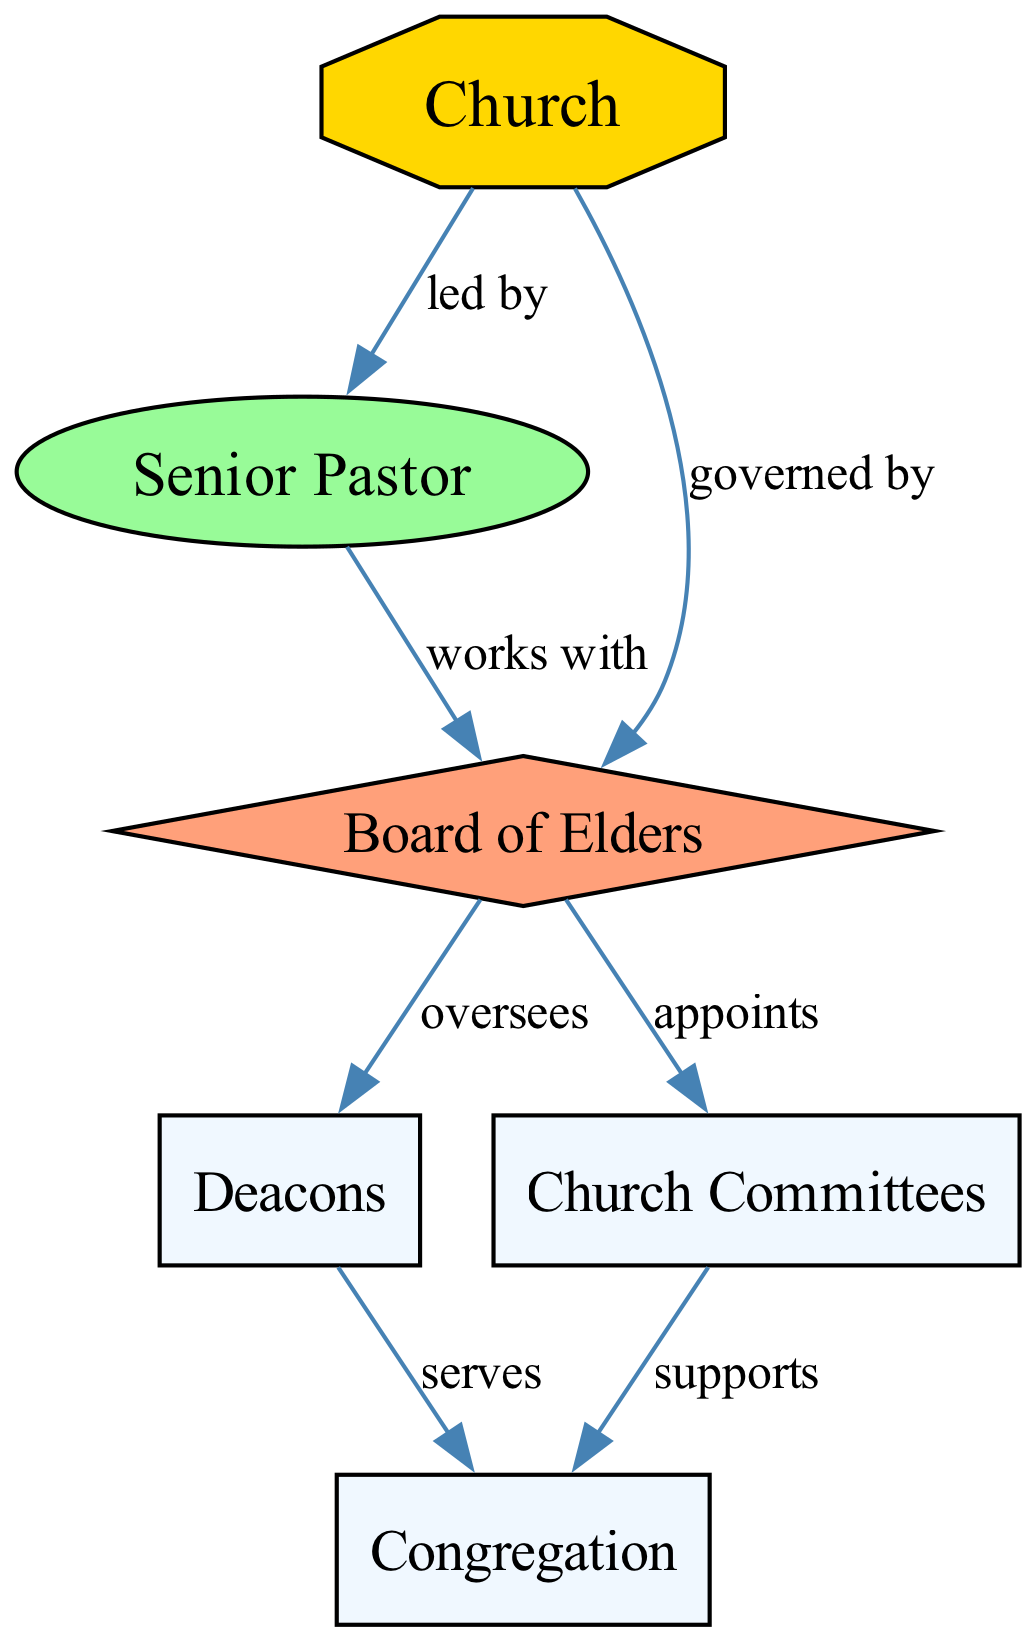What is the main governing body of the church? The diagram indicates that the church is governed by the Board of Elders, which is directly represented as connected to the church node with the label "governed by."
Answer: Board of Elders Who does the Senior Pastor work with? The diagram shows a direct connection from the Senior Pastor to the Board of Elders labeled "works with." Therefore, the Senior Pastor collaborates with the Board of Elders.
Answer: Board of Elders How many main roles are identified in the diagram? By counting the unique nodes present in the diagram that represent different roles, we find a total of six nodes: Church, Senior Pastor, Board of Elders, Deacons, Church Committees, and Congregation.
Answer: Six Which role oversees the Deacons? The edge labeled "oversees" points from the Board of Elders to the Deacons, indicating that the Board of Elders is in charge of overseeing the Deacons.
Answer: Board of Elders What do Deacons serve? The connection labeled "serves" shows that Deacons are connected to the Congregation, meaning they serve the Congregation.
Answer: Congregation What is the relationship between Church Committees and the Congregation? The edge labeled "supports" connects the Church Committees to the Congregation, indicating that the Church Committees provide support to the Congregation.
Answer: Supports Which entity has the highest organizational authority in the structure? The diagram indicates the Church as the central entity, which is the topmost point in the structure and directly leads to the Senior Pastor, and is governed by the Board of Elders. Thus, the Church possesses the highest authority.
Answer: Church How are Church Committees appointed? The diagram shows that the Board of Elders appoints the Church Committees, as indicated by the directed edge labeled "appoints." This means the selection of Church Committees is under the authority of the Board of Elders.
Answer: Board of Elders What type of diagram is represented here? Given that this diagram depicts entities and their relationships succinctly, showing how various roles interact within the church setting, it exemplifies a Concept map.
Answer: Concept map 